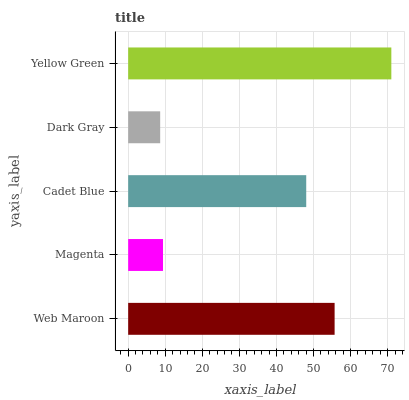Is Dark Gray the minimum?
Answer yes or no. Yes. Is Yellow Green the maximum?
Answer yes or no. Yes. Is Magenta the minimum?
Answer yes or no. No. Is Magenta the maximum?
Answer yes or no. No. Is Web Maroon greater than Magenta?
Answer yes or no. Yes. Is Magenta less than Web Maroon?
Answer yes or no. Yes. Is Magenta greater than Web Maroon?
Answer yes or no. No. Is Web Maroon less than Magenta?
Answer yes or no. No. Is Cadet Blue the high median?
Answer yes or no. Yes. Is Cadet Blue the low median?
Answer yes or no. Yes. Is Dark Gray the high median?
Answer yes or no. No. Is Magenta the low median?
Answer yes or no. No. 